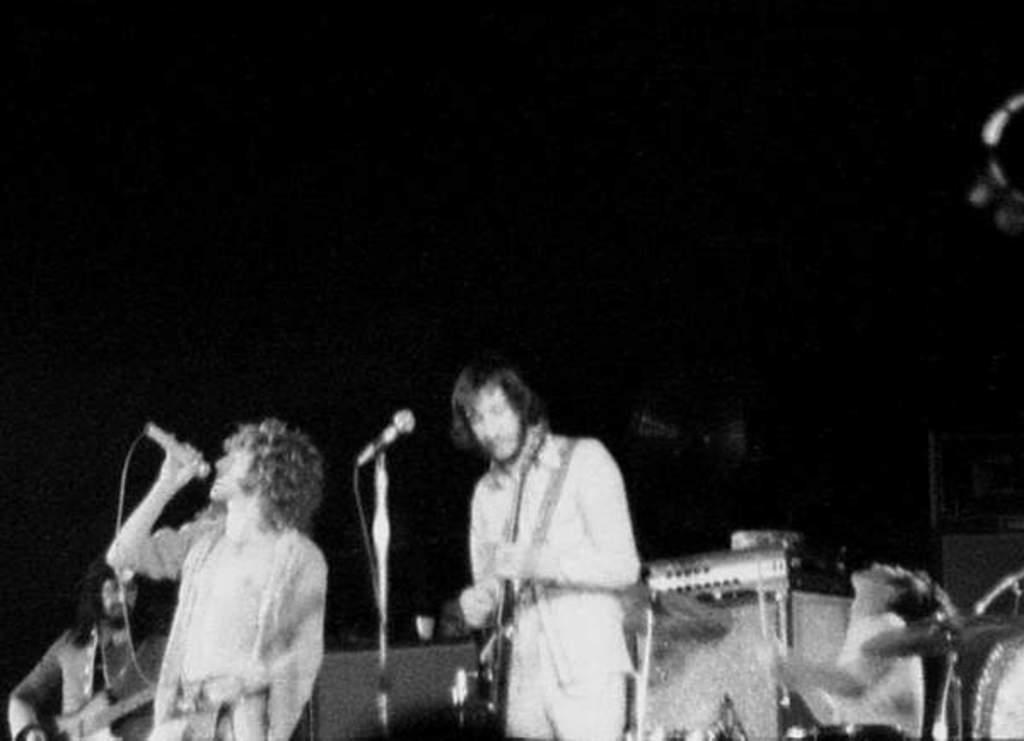Please provide a concise description of this image. Here this is a black and white image, in which we can see two persons playing guitars and other person is singing song with the help of microphone in his hands and we can also see a microphone present on the stage with the help of stand and on the right side we can see some musical instruments present and we can also see drums present on the extreme right side. 